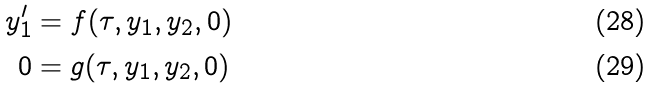<formula> <loc_0><loc_0><loc_500><loc_500>y _ { 1 } ^ { \prime } & = f ( \tau , y _ { 1 } , y _ { 2 } , 0 ) \\ 0 & = g ( \tau , y _ { 1 } , y _ { 2 } , 0 )</formula> 